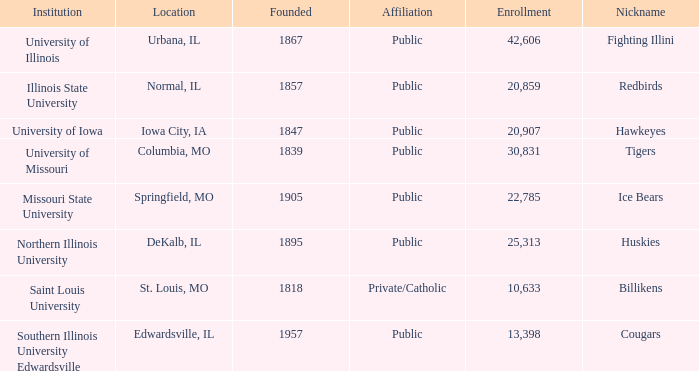What is Southern Illinois University Edwardsville's affiliation? Public. 